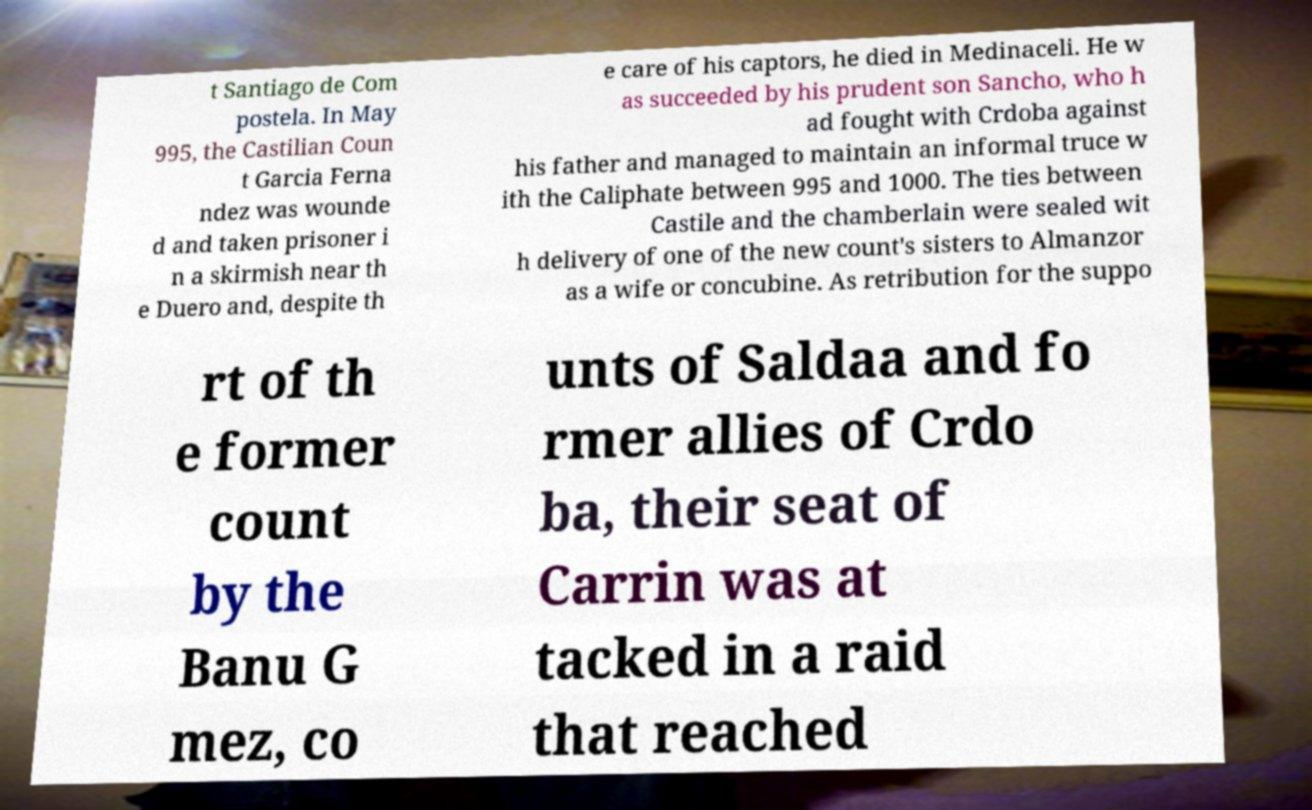I need the written content from this picture converted into text. Can you do that? t Santiago de Com postela. In May 995, the Castilian Coun t Garcia Ferna ndez was wounde d and taken prisoner i n a skirmish near th e Duero and, despite th e care of his captors, he died in Medinaceli. He w as succeeded by his prudent son Sancho, who h ad fought with Crdoba against his father and managed to maintain an informal truce w ith the Caliphate between 995 and 1000. The ties between Castile and the chamberlain were sealed wit h delivery of one of the new count's sisters to Almanzor as a wife or concubine. As retribution for the suppo rt of th e former count by the Banu G mez, co unts of Saldaa and fo rmer allies of Crdo ba, their seat of Carrin was at tacked in a raid that reached 